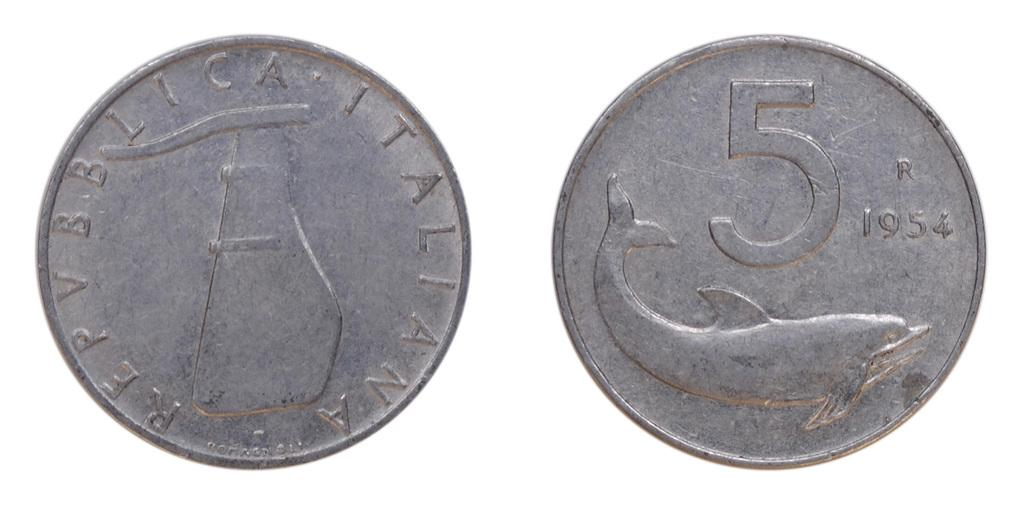<image>
Offer a succinct explanation of the picture presented. A silver coin with a dolphin on it, with the date 1954. 